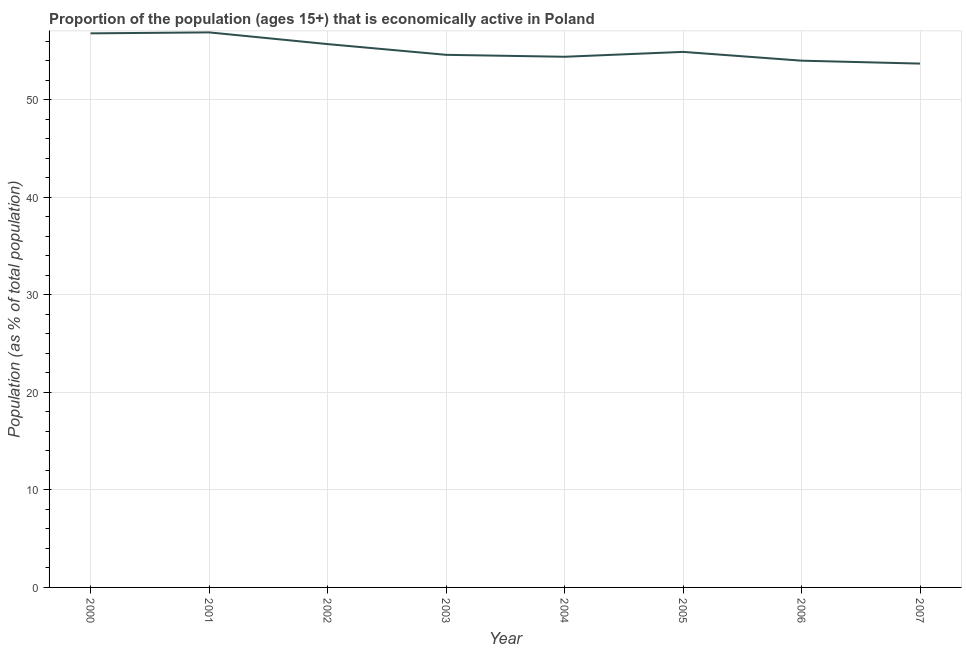What is the percentage of economically active population in 2004?
Offer a very short reply. 54.4. Across all years, what is the maximum percentage of economically active population?
Make the answer very short. 56.9. Across all years, what is the minimum percentage of economically active population?
Your answer should be compact. 53.7. In which year was the percentage of economically active population maximum?
Make the answer very short. 2001. What is the sum of the percentage of economically active population?
Keep it short and to the point. 441. What is the difference between the percentage of economically active population in 2002 and 2004?
Give a very brief answer. 1.3. What is the average percentage of economically active population per year?
Keep it short and to the point. 55.13. What is the median percentage of economically active population?
Provide a succinct answer. 54.75. In how many years, is the percentage of economically active population greater than 10 %?
Your answer should be compact. 8. Do a majority of the years between 2001 and 2003 (inclusive) have percentage of economically active population greater than 34 %?
Keep it short and to the point. Yes. What is the ratio of the percentage of economically active population in 2000 to that in 2002?
Offer a terse response. 1.02. Is the percentage of economically active population in 2002 less than that in 2003?
Ensure brevity in your answer.  No. What is the difference between the highest and the second highest percentage of economically active population?
Keep it short and to the point. 0.1. Is the sum of the percentage of economically active population in 2006 and 2007 greater than the maximum percentage of economically active population across all years?
Your response must be concise. Yes. What is the difference between the highest and the lowest percentage of economically active population?
Make the answer very short. 3.2. How many lines are there?
Offer a terse response. 1. Are the values on the major ticks of Y-axis written in scientific E-notation?
Your response must be concise. No. Does the graph contain any zero values?
Keep it short and to the point. No. What is the title of the graph?
Your answer should be very brief. Proportion of the population (ages 15+) that is economically active in Poland. What is the label or title of the Y-axis?
Offer a very short reply. Population (as % of total population). What is the Population (as % of total population) in 2000?
Your response must be concise. 56.8. What is the Population (as % of total population) of 2001?
Keep it short and to the point. 56.9. What is the Population (as % of total population) in 2002?
Your answer should be very brief. 55.7. What is the Population (as % of total population) in 2003?
Provide a succinct answer. 54.6. What is the Population (as % of total population) of 2004?
Provide a succinct answer. 54.4. What is the Population (as % of total population) of 2005?
Offer a very short reply. 54.9. What is the Population (as % of total population) of 2006?
Provide a succinct answer. 54. What is the Population (as % of total population) of 2007?
Your response must be concise. 53.7. What is the difference between the Population (as % of total population) in 2000 and 2002?
Offer a very short reply. 1.1. What is the difference between the Population (as % of total population) in 2000 and 2003?
Your answer should be compact. 2.2. What is the difference between the Population (as % of total population) in 2000 and 2006?
Provide a short and direct response. 2.8. What is the difference between the Population (as % of total population) in 2000 and 2007?
Your response must be concise. 3.1. What is the difference between the Population (as % of total population) in 2001 and 2002?
Your answer should be compact. 1.2. What is the difference between the Population (as % of total population) in 2001 and 2003?
Provide a succinct answer. 2.3. What is the difference between the Population (as % of total population) in 2001 and 2004?
Provide a short and direct response. 2.5. What is the difference between the Population (as % of total population) in 2001 and 2006?
Offer a terse response. 2.9. What is the difference between the Population (as % of total population) in 2002 and 2003?
Provide a succinct answer. 1.1. What is the difference between the Population (as % of total population) in 2002 and 2004?
Make the answer very short. 1.3. What is the difference between the Population (as % of total population) in 2002 and 2005?
Your answer should be compact. 0.8. What is the difference between the Population (as % of total population) in 2002 and 2006?
Provide a succinct answer. 1.7. What is the difference between the Population (as % of total population) in 2002 and 2007?
Offer a terse response. 2. What is the difference between the Population (as % of total population) in 2003 and 2004?
Provide a succinct answer. 0.2. What is the difference between the Population (as % of total population) in 2003 and 2006?
Provide a succinct answer. 0.6. What is the difference between the Population (as % of total population) in 2003 and 2007?
Offer a terse response. 0.9. What is the difference between the Population (as % of total population) in 2004 and 2005?
Your answer should be compact. -0.5. What is the difference between the Population (as % of total population) in 2004 and 2006?
Offer a terse response. 0.4. What is the ratio of the Population (as % of total population) in 2000 to that in 2002?
Provide a succinct answer. 1.02. What is the ratio of the Population (as % of total population) in 2000 to that in 2003?
Provide a succinct answer. 1.04. What is the ratio of the Population (as % of total population) in 2000 to that in 2004?
Ensure brevity in your answer.  1.04. What is the ratio of the Population (as % of total population) in 2000 to that in 2005?
Provide a short and direct response. 1.03. What is the ratio of the Population (as % of total population) in 2000 to that in 2006?
Provide a succinct answer. 1.05. What is the ratio of the Population (as % of total population) in 2000 to that in 2007?
Offer a terse response. 1.06. What is the ratio of the Population (as % of total population) in 2001 to that in 2002?
Offer a terse response. 1.02. What is the ratio of the Population (as % of total population) in 2001 to that in 2003?
Your answer should be very brief. 1.04. What is the ratio of the Population (as % of total population) in 2001 to that in 2004?
Keep it short and to the point. 1.05. What is the ratio of the Population (as % of total population) in 2001 to that in 2005?
Keep it short and to the point. 1.04. What is the ratio of the Population (as % of total population) in 2001 to that in 2006?
Your answer should be compact. 1.05. What is the ratio of the Population (as % of total population) in 2001 to that in 2007?
Your answer should be compact. 1.06. What is the ratio of the Population (as % of total population) in 2002 to that in 2003?
Offer a terse response. 1.02. What is the ratio of the Population (as % of total population) in 2002 to that in 2004?
Your answer should be compact. 1.02. What is the ratio of the Population (as % of total population) in 2002 to that in 2006?
Keep it short and to the point. 1.03. What is the ratio of the Population (as % of total population) in 2003 to that in 2005?
Offer a very short reply. 0.99. What is the ratio of the Population (as % of total population) in 2003 to that in 2007?
Provide a short and direct response. 1.02. What is the ratio of the Population (as % of total population) in 2004 to that in 2005?
Ensure brevity in your answer.  0.99. What is the ratio of the Population (as % of total population) in 2004 to that in 2007?
Keep it short and to the point. 1.01. What is the ratio of the Population (as % of total population) in 2006 to that in 2007?
Provide a succinct answer. 1.01. 